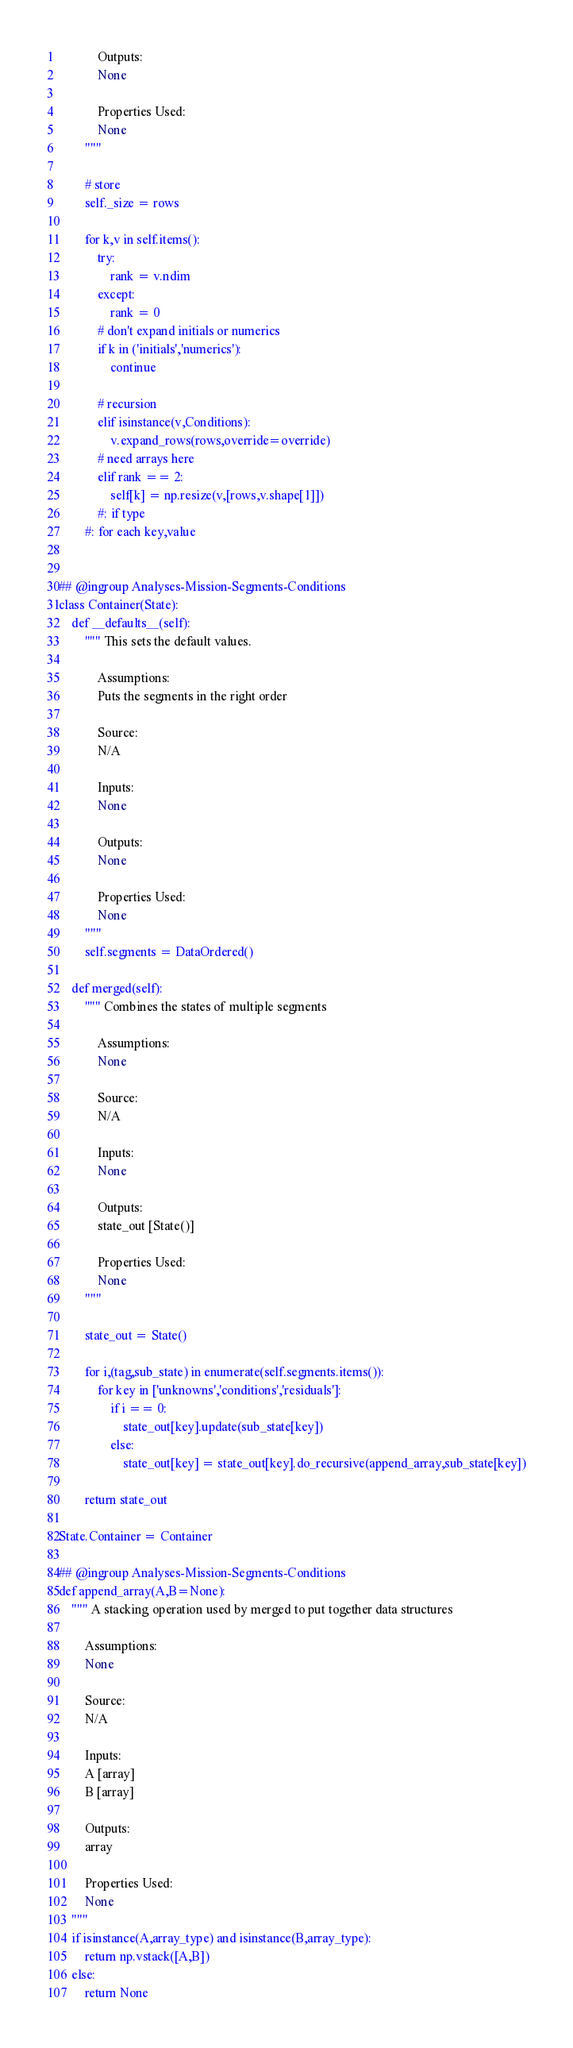<code> <loc_0><loc_0><loc_500><loc_500><_Python_>            Outputs:
            None
    
            Properties Used:
            None
        """         
        
        # store
        self._size = rows
        
        for k,v in self.items(): 
            try:
                rank = v.ndim
            except:
                rank = 0            
            # don't expand initials or numerics
            if k in ('initials','numerics'):
                continue
            
            # recursion
            elif isinstance(v,Conditions):
                v.expand_rows(rows,override=override)
            # need arrays here
            elif rank == 2:
                self[k] = np.resize(v,[rows,v.shape[1]])
            #: if type
        #: for each key,value        
        
        
## @ingroup Analyses-Mission-Segments-Conditions        
class Container(State):
    def __defaults__(self):
        """ This sets the default values.
    
            Assumptions:
            Puts the segments in the right order
    
            Source:
            N/A
    
            Inputs:
            None
    
            Outputs:
            None
    
            Properties Used:
            None
        """         
        self.segments = DataOrdered()
        
    def merged(self):
        """ Combines the states of multiple segments
    
            Assumptions:
            None
    
            Source:
            N/A
    
            Inputs:
            None
    
            Outputs:
            state_out [State()]
    
            Properties Used:
            None
        """              
        
        state_out = State()
        
        for i,(tag,sub_state) in enumerate(self.segments.items()):
            for key in ['unknowns','conditions','residuals']:
                if i == 0:
                    state_out[key].update(sub_state[key])
                else:
                    state_out[key] = state_out[key].do_recursive(append_array,sub_state[key])
            
        return state_out
        
State.Container = Container

## @ingroup Analyses-Mission-Segments-Conditions
def append_array(A,B=None):
    """ A stacking operation used by merged to put together data structures

        Assumptions:
        None

        Source:
        N/A

        Inputs:
        A [array]
        B [array]

        Outputs:
        array

        Properties Used:
        None
    """       
    if isinstance(A,array_type) and isinstance(B,array_type):
        return np.vstack([A,B])
    else:
        return None</code> 